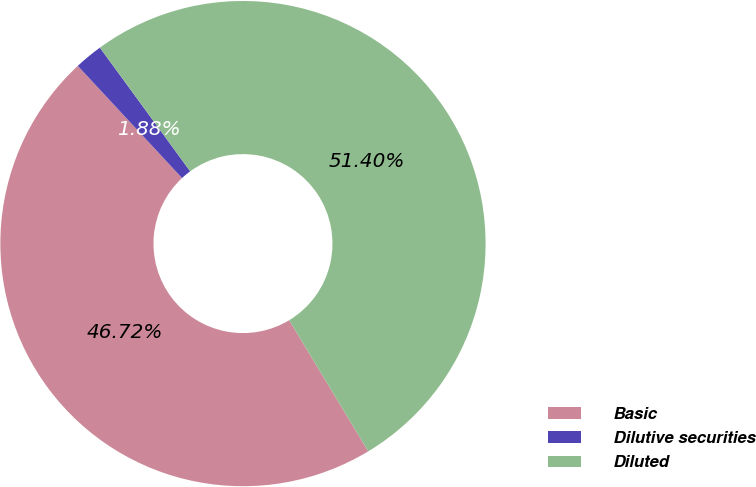<chart> <loc_0><loc_0><loc_500><loc_500><pie_chart><fcel>Basic<fcel>Dilutive securities<fcel>Diluted<nl><fcel>46.72%<fcel>1.88%<fcel>51.4%<nl></chart> 